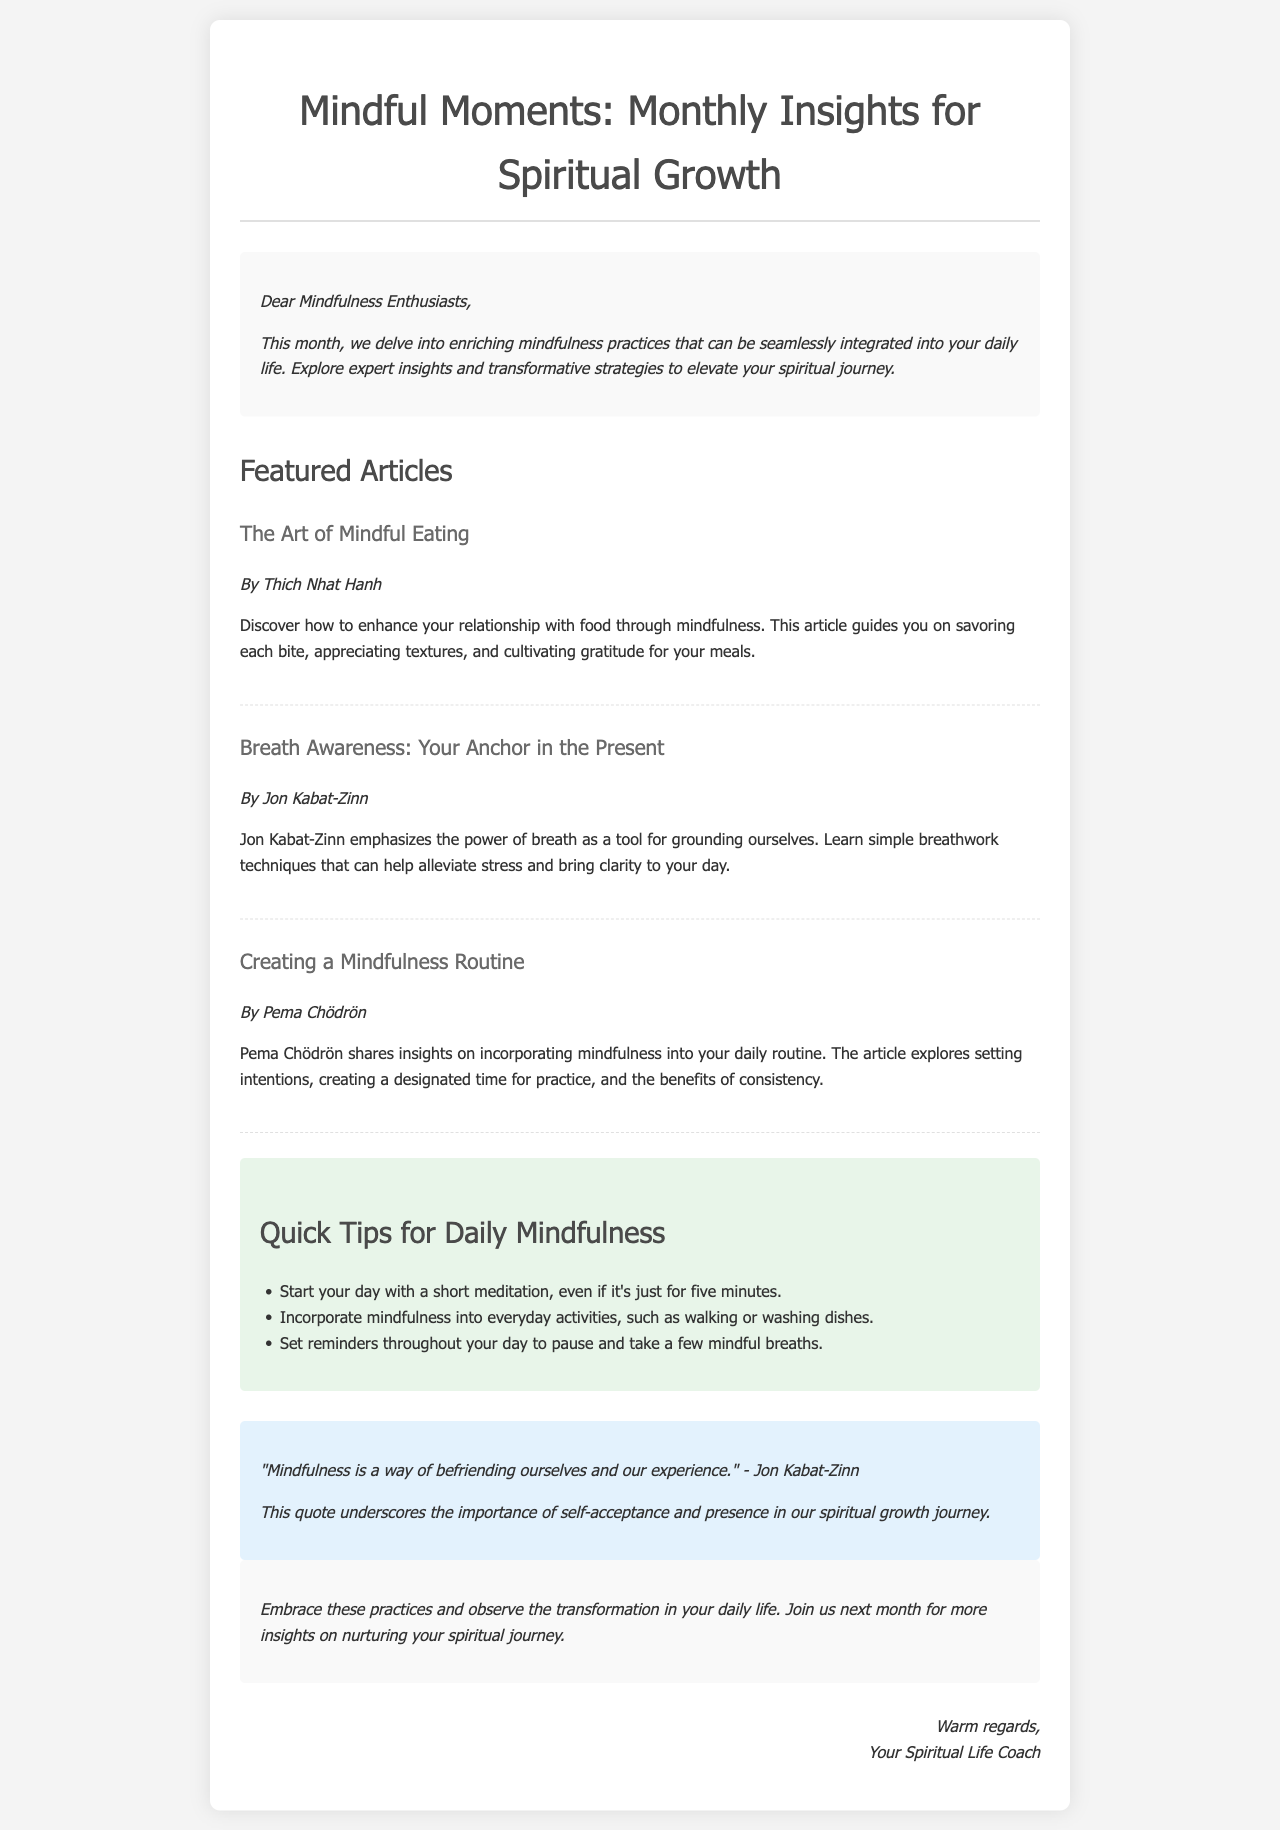What is the title of the newsletter? The title is prominently displayed at the top of the document, indicating the focus of the content on mindfulness and spiritual growth.
Answer: Mindful Moments: Monthly Insights for Spiritual Growth Who is the author of “The Art of Mindful Eating”? Each featured article lists its author, showcasing contributions from various mindfulness experts.
Answer: Thich Nhat Hanh What is one quick tip for daily mindfulness? The tips section includes practical strategies for incorporating mindfulness into everyday life, with examples.
Answer: Start your day with a short meditation, even if it's just for five minutes Which expert emphasizes the power of breath? The article references an expert who discusses breath awareness and its significance in mindfulness practices.
Answer: Jon Kabat-Zinn What is the main theme of the newsletter? The overall theme is summarized in the introductory paragraph, explaining the focus of the newsletter on mindfulness practices.
Answer: Mindfulness practices that can be seamlessly integrated into daily life 